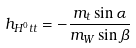Convert formula to latex. <formula><loc_0><loc_0><loc_500><loc_500>h _ { H ^ { 0 } t t } = - \frac { m _ { t } \sin \alpha } { m _ { W } \sin \beta }</formula> 